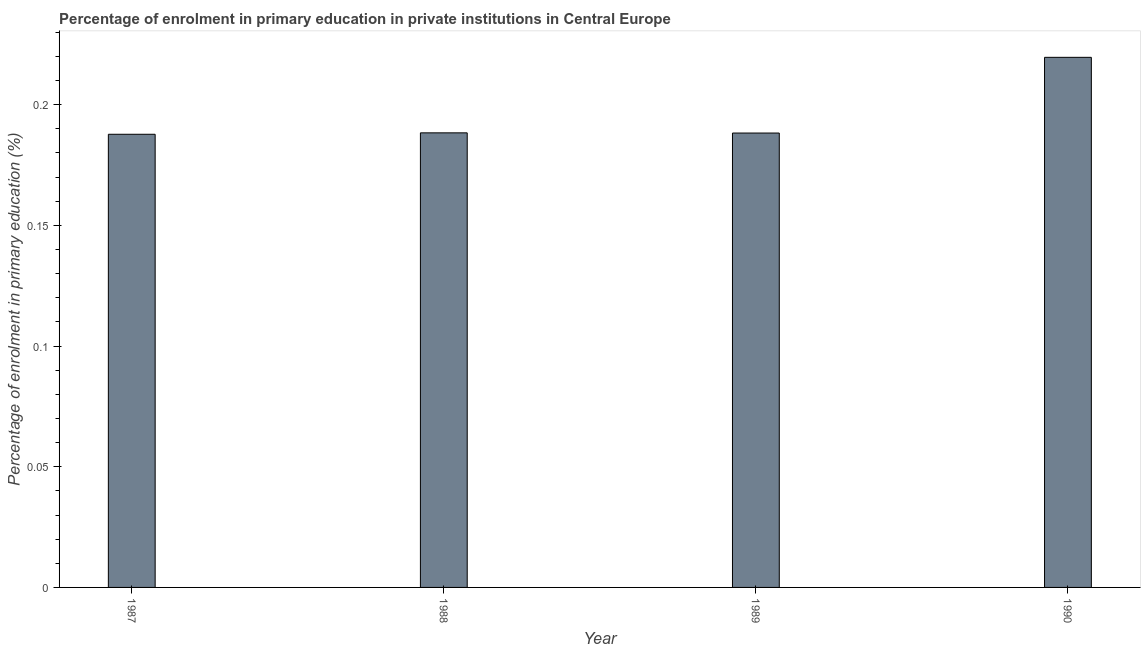Does the graph contain grids?
Your answer should be compact. No. What is the title of the graph?
Provide a short and direct response. Percentage of enrolment in primary education in private institutions in Central Europe. What is the label or title of the X-axis?
Offer a very short reply. Year. What is the label or title of the Y-axis?
Make the answer very short. Percentage of enrolment in primary education (%). What is the enrolment percentage in primary education in 1988?
Give a very brief answer. 0.19. Across all years, what is the maximum enrolment percentage in primary education?
Offer a terse response. 0.22. Across all years, what is the minimum enrolment percentage in primary education?
Offer a terse response. 0.19. In which year was the enrolment percentage in primary education minimum?
Give a very brief answer. 1987. What is the sum of the enrolment percentage in primary education?
Your answer should be compact. 0.78. What is the difference between the enrolment percentage in primary education in 1987 and 1990?
Offer a very short reply. -0.03. What is the average enrolment percentage in primary education per year?
Keep it short and to the point. 0.2. What is the median enrolment percentage in primary education?
Make the answer very short. 0.19. What is the ratio of the enrolment percentage in primary education in 1989 to that in 1990?
Your response must be concise. 0.86. Is the enrolment percentage in primary education in 1989 less than that in 1990?
Provide a short and direct response. Yes. What is the difference between the highest and the second highest enrolment percentage in primary education?
Your response must be concise. 0.03. How many bars are there?
Give a very brief answer. 4. Are all the bars in the graph horizontal?
Keep it short and to the point. No. How many years are there in the graph?
Your answer should be very brief. 4. What is the Percentage of enrolment in primary education (%) of 1987?
Provide a short and direct response. 0.19. What is the Percentage of enrolment in primary education (%) of 1988?
Make the answer very short. 0.19. What is the Percentage of enrolment in primary education (%) of 1989?
Give a very brief answer. 0.19. What is the Percentage of enrolment in primary education (%) of 1990?
Provide a short and direct response. 0.22. What is the difference between the Percentage of enrolment in primary education (%) in 1987 and 1988?
Offer a very short reply. -0. What is the difference between the Percentage of enrolment in primary education (%) in 1987 and 1989?
Your answer should be very brief. -0. What is the difference between the Percentage of enrolment in primary education (%) in 1987 and 1990?
Give a very brief answer. -0.03. What is the difference between the Percentage of enrolment in primary education (%) in 1988 and 1989?
Your answer should be compact. 8e-5. What is the difference between the Percentage of enrolment in primary education (%) in 1988 and 1990?
Offer a terse response. -0.03. What is the difference between the Percentage of enrolment in primary education (%) in 1989 and 1990?
Make the answer very short. -0.03. What is the ratio of the Percentage of enrolment in primary education (%) in 1987 to that in 1989?
Ensure brevity in your answer.  1. What is the ratio of the Percentage of enrolment in primary education (%) in 1987 to that in 1990?
Give a very brief answer. 0.85. What is the ratio of the Percentage of enrolment in primary education (%) in 1988 to that in 1989?
Give a very brief answer. 1. What is the ratio of the Percentage of enrolment in primary education (%) in 1988 to that in 1990?
Give a very brief answer. 0.86. What is the ratio of the Percentage of enrolment in primary education (%) in 1989 to that in 1990?
Your answer should be compact. 0.86. 